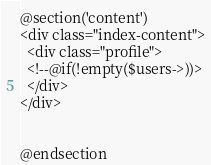<code> <loc_0><loc_0><loc_500><loc_500><_PHP_>
@section('content')
<div class="index-content">
  <div class="profile">
  <!--@if(!empty($users->))>
  </div>
</div>


@endsection
</code> 